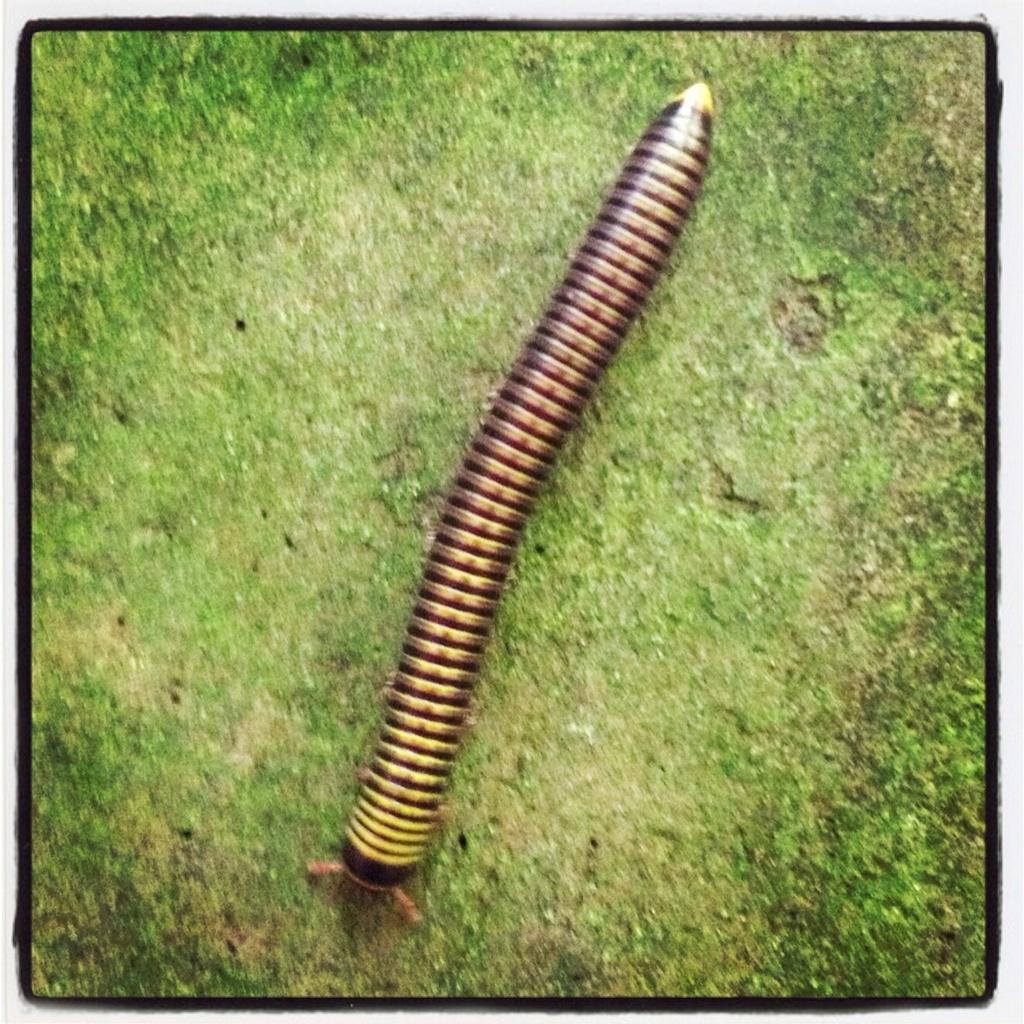How would you summarize this image in a sentence or two? In this image we can see an insect on the ground. 